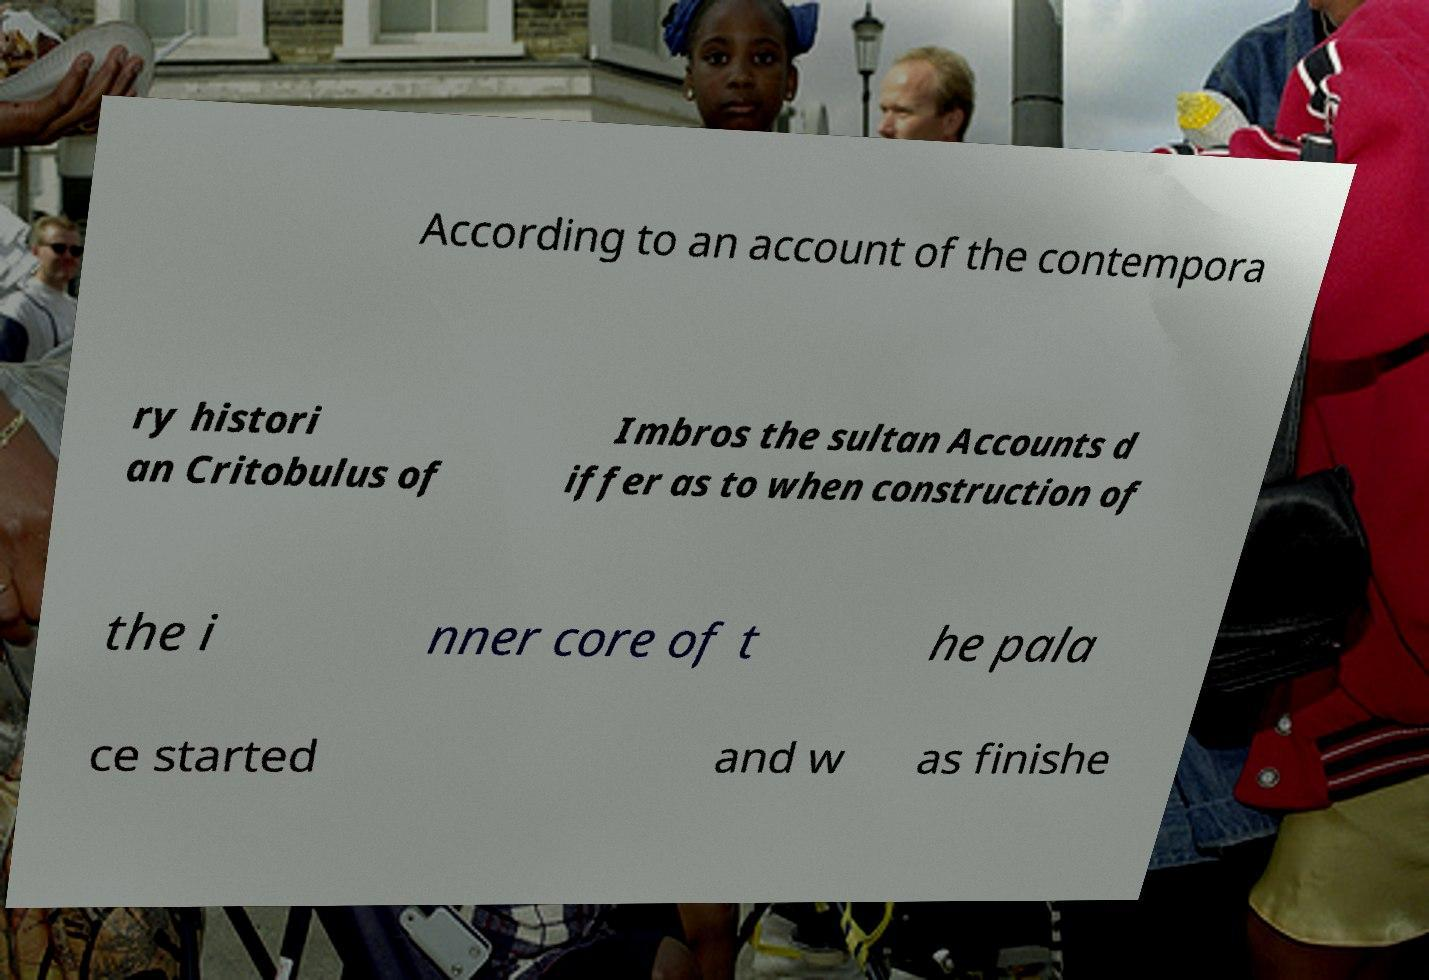I need the written content from this picture converted into text. Can you do that? According to an account of the contempora ry histori an Critobulus of Imbros the sultan Accounts d iffer as to when construction of the i nner core of t he pala ce started and w as finishe 